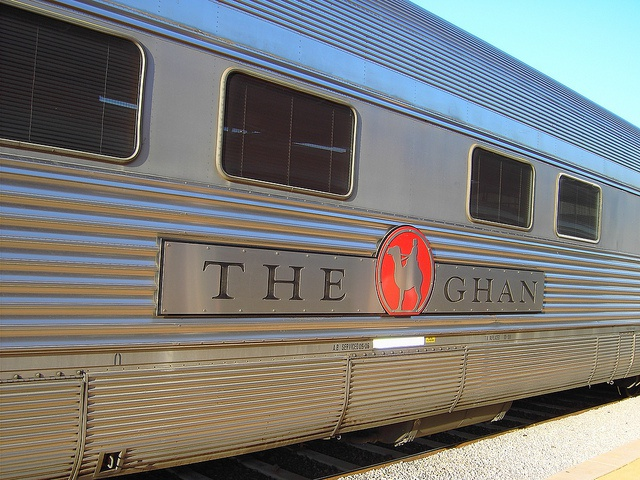Describe the objects in this image and their specific colors. I can see a train in gray, darkgray, black, and tan tones in this image. 